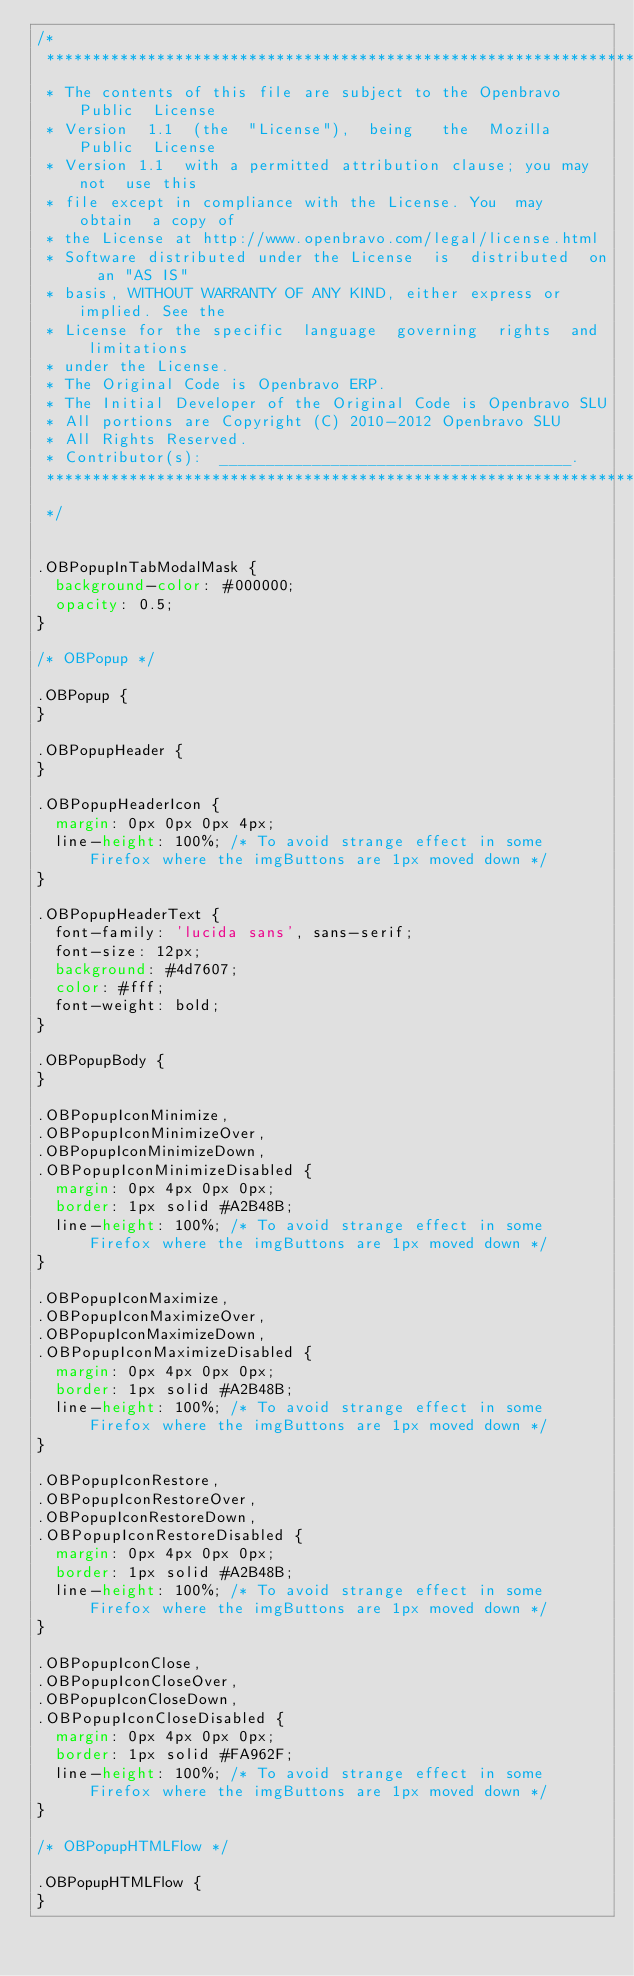Convert code to text. <code><loc_0><loc_0><loc_500><loc_500><_CSS_>/*
 *************************************************************************
 * The contents of this file are subject to the Openbravo  Public  License
 * Version  1.1  (the  "License"),  being   the  Mozilla   Public  License
 * Version 1.1  with a permitted attribution clause; you may not  use this
 * file except in compliance with the License. You  may  obtain  a copy of
 * the License at http://www.openbravo.com/legal/license.html 
 * Software distributed under the License  is  distributed  on  an "AS IS"
 * basis, WITHOUT WARRANTY OF ANY KIND, either express or implied. See the
 * License for the specific  language  governing  rights  and  limitations
 * under the License.
 * The Original Code is Openbravo ERP.
 * The Initial Developer of the Original Code is Openbravo SLU
 * All portions are Copyright (C) 2010-2012 Openbravo SLU
 * All Rights Reserved.
 * Contributor(s):  ______________________________________.
 ************************************************************************
 */


.OBPopupInTabModalMask {
  background-color: #000000;
  opacity: 0.5;
}

/* OBPopup */

.OBPopup {
}

.OBPopupHeader {
}

.OBPopupHeaderIcon {
  margin: 0px 0px 0px 4px;
  line-height: 100%; /* To avoid strange effect in some Firefox where the imgButtons are 1px moved down */
}

.OBPopupHeaderText {
  font-family: 'lucida sans', sans-serif;
  font-size: 12px;
  background: #4d7607;
  color: #fff;
  font-weight: bold;
}

.OBPopupBody {
}

.OBPopupIconMinimize,
.OBPopupIconMinimizeOver,
.OBPopupIconMinimizeDown,
.OBPopupIconMinimizeDisabled {
  margin: 0px 4px 0px 0px;
  border: 1px solid #A2B48B;
  line-height: 100%; /* To avoid strange effect in some Firefox where the imgButtons are 1px moved down */
}

.OBPopupIconMaximize,
.OBPopupIconMaximizeOver,
.OBPopupIconMaximizeDown,
.OBPopupIconMaximizeDisabled {
  margin: 0px 4px 0px 0px;
  border: 1px solid #A2B48B;
  line-height: 100%; /* To avoid strange effect in some Firefox where the imgButtons are 1px moved down */
}

.OBPopupIconRestore,
.OBPopupIconRestoreOver,
.OBPopupIconRestoreDown,
.OBPopupIconRestoreDisabled {
  margin: 0px 4px 0px 0px;
  border: 1px solid #A2B48B;
  line-height: 100%; /* To avoid strange effect in some Firefox where the imgButtons are 1px moved down */
}

.OBPopupIconClose,
.OBPopupIconCloseOver,
.OBPopupIconCloseDown,
.OBPopupIconCloseDisabled {
  margin: 0px 4px 0px 0px;
  border: 1px solid #FA962F;
  line-height: 100%; /* To avoid strange effect in some Firefox where the imgButtons are 1px moved down */
}

/* OBPopupHTMLFlow */

.OBPopupHTMLFlow {
}</code> 